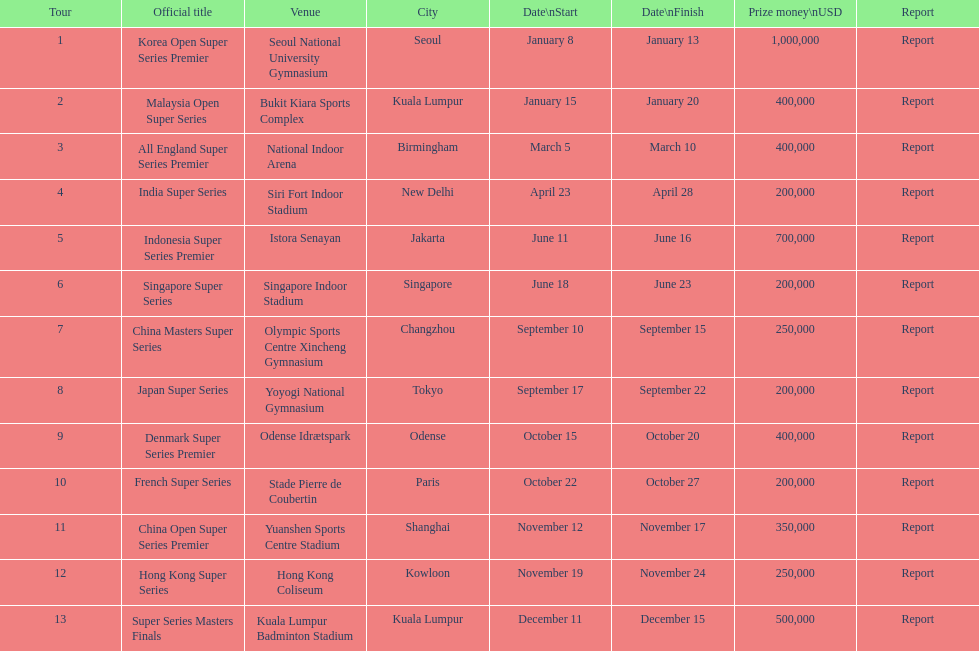Which tournament shares the same prize money amount as the french super series? Japan Super Series, Singapore Super Series, India Super Series. 